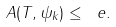<formula> <loc_0><loc_0><loc_500><loc_500>A ( T , \psi _ { k } ) \leq \ e .</formula> 